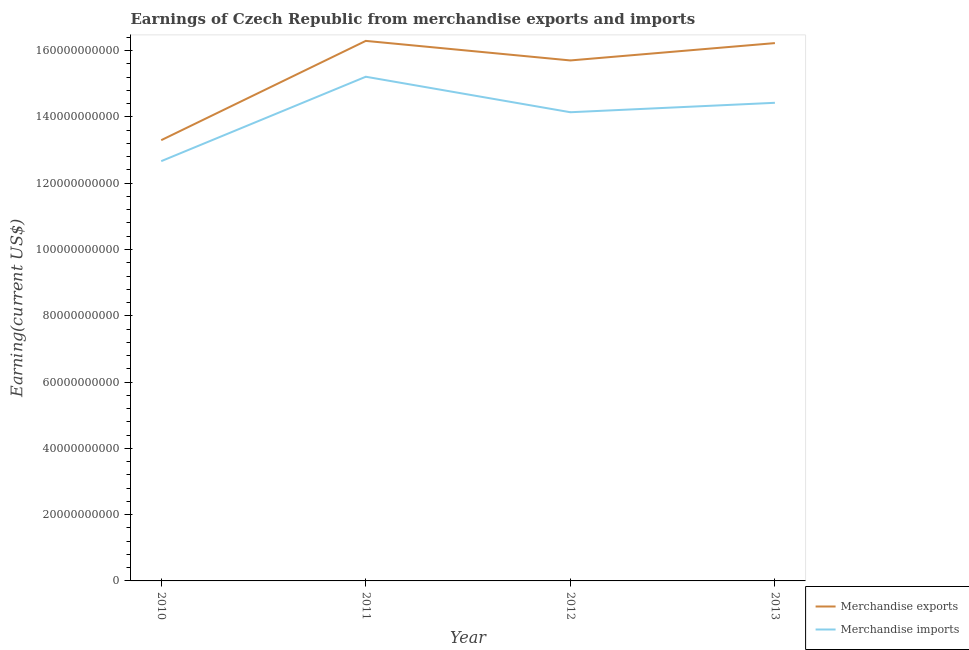Is the number of lines equal to the number of legend labels?
Offer a terse response. Yes. What is the earnings from merchandise imports in 2012?
Offer a terse response. 1.41e+11. Across all years, what is the maximum earnings from merchandise imports?
Provide a short and direct response. 1.52e+11. Across all years, what is the minimum earnings from merchandise exports?
Your answer should be very brief. 1.33e+11. In which year was the earnings from merchandise exports maximum?
Give a very brief answer. 2011. In which year was the earnings from merchandise exports minimum?
Ensure brevity in your answer.  2010. What is the total earnings from merchandise imports in the graph?
Offer a terse response. 5.64e+11. What is the difference between the earnings from merchandise exports in 2011 and that in 2013?
Offer a very short reply. 6.65e+08. What is the difference between the earnings from merchandise imports in 2012 and the earnings from merchandise exports in 2011?
Make the answer very short. -2.15e+1. What is the average earnings from merchandise imports per year?
Your answer should be compact. 1.41e+11. In the year 2012, what is the difference between the earnings from merchandise exports and earnings from merchandise imports?
Provide a succinct answer. 1.56e+1. What is the ratio of the earnings from merchandise exports in 2010 to that in 2012?
Your answer should be very brief. 0.85. Is the earnings from merchandise imports in 2012 less than that in 2013?
Your answer should be compact. Yes. What is the difference between the highest and the second highest earnings from merchandise exports?
Provide a short and direct response. 6.65e+08. What is the difference between the highest and the lowest earnings from merchandise imports?
Offer a very short reply. 2.55e+1. Is the sum of the earnings from merchandise imports in 2010 and 2013 greater than the maximum earnings from merchandise exports across all years?
Provide a short and direct response. Yes. Is the earnings from merchandise imports strictly greater than the earnings from merchandise exports over the years?
Keep it short and to the point. No. How many lines are there?
Give a very brief answer. 2. How many years are there in the graph?
Your response must be concise. 4. Does the graph contain any zero values?
Your answer should be very brief. No. How many legend labels are there?
Provide a succinct answer. 2. What is the title of the graph?
Provide a succinct answer. Earnings of Czech Republic from merchandise exports and imports. Does "Private creditors" appear as one of the legend labels in the graph?
Keep it short and to the point. No. What is the label or title of the Y-axis?
Offer a terse response. Earning(current US$). What is the Earning(current US$) of Merchandise exports in 2010?
Your answer should be compact. 1.33e+11. What is the Earning(current US$) of Merchandise imports in 2010?
Offer a terse response. 1.27e+11. What is the Earning(current US$) of Merchandise exports in 2011?
Give a very brief answer. 1.63e+11. What is the Earning(current US$) of Merchandise imports in 2011?
Make the answer very short. 1.52e+11. What is the Earning(current US$) in Merchandise exports in 2012?
Provide a succinct answer. 1.57e+11. What is the Earning(current US$) in Merchandise imports in 2012?
Provide a succinct answer. 1.41e+11. What is the Earning(current US$) in Merchandise exports in 2013?
Offer a terse response. 1.62e+11. What is the Earning(current US$) in Merchandise imports in 2013?
Ensure brevity in your answer.  1.44e+11. Across all years, what is the maximum Earning(current US$) in Merchandise exports?
Your answer should be very brief. 1.63e+11. Across all years, what is the maximum Earning(current US$) of Merchandise imports?
Make the answer very short. 1.52e+11. Across all years, what is the minimum Earning(current US$) in Merchandise exports?
Your answer should be very brief. 1.33e+11. Across all years, what is the minimum Earning(current US$) of Merchandise imports?
Your answer should be compact. 1.27e+11. What is the total Earning(current US$) in Merchandise exports in the graph?
Make the answer very short. 6.15e+11. What is the total Earning(current US$) of Merchandise imports in the graph?
Offer a very short reply. 5.64e+11. What is the difference between the Earning(current US$) of Merchandise exports in 2010 and that in 2011?
Offer a terse response. -3.00e+1. What is the difference between the Earning(current US$) of Merchandise imports in 2010 and that in 2011?
Ensure brevity in your answer.  -2.55e+1. What is the difference between the Earning(current US$) of Merchandise exports in 2010 and that in 2012?
Offer a very short reply. -2.41e+1. What is the difference between the Earning(current US$) of Merchandise imports in 2010 and that in 2012?
Provide a short and direct response. -1.48e+1. What is the difference between the Earning(current US$) of Merchandise exports in 2010 and that in 2013?
Give a very brief answer. -2.93e+1. What is the difference between the Earning(current US$) in Merchandise imports in 2010 and that in 2013?
Keep it short and to the point. -1.76e+1. What is the difference between the Earning(current US$) in Merchandise exports in 2011 and that in 2012?
Make the answer very short. 5.90e+09. What is the difference between the Earning(current US$) of Merchandise imports in 2011 and that in 2012?
Your answer should be compact. 1.07e+1. What is the difference between the Earning(current US$) in Merchandise exports in 2011 and that in 2013?
Offer a terse response. 6.65e+08. What is the difference between the Earning(current US$) in Merchandise imports in 2011 and that in 2013?
Offer a terse response. 7.87e+09. What is the difference between the Earning(current US$) of Merchandise exports in 2012 and that in 2013?
Your response must be concise. -5.23e+09. What is the difference between the Earning(current US$) of Merchandise imports in 2012 and that in 2013?
Make the answer very short. -2.85e+09. What is the difference between the Earning(current US$) in Merchandise exports in 2010 and the Earning(current US$) in Merchandise imports in 2011?
Give a very brief answer. -1.91e+1. What is the difference between the Earning(current US$) in Merchandise exports in 2010 and the Earning(current US$) in Merchandise imports in 2012?
Ensure brevity in your answer.  -8.43e+09. What is the difference between the Earning(current US$) of Merchandise exports in 2010 and the Earning(current US$) of Merchandise imports in 2013?
Your answer should be very brief. -1.13e+1. What is the difference between the Earning(current US$) of Merchandise exports in 2011 and the Earning(current US$) of Merchandise imports in 2012?
Offer a terse response. 2.15e+1. What is the difference between the Earning(current US$) of Merchandise exports in 2011 and the Earning(current US$) of Merchandise imports in 2013?
Provide a short and direct response. 1.87e+1. What is the difference between the Earning(current US$) in Merchandise exports in 2012 and the Earning(current US$) in Merchandise imports in 2013?
Your answer should be very brief. 1.28e+1. What is the average Earning(current US$) of Merchandise exports per year?
Your response must be concise. 1.54e+11. What is the average Earning(current US$) in Merchandise imports per year?
Provide a succinct answer. 1.41e+11. In the year 2010, what is the difference between the Earning(current US$) of Merchandise exports and Earning(current US$) of Merchandise imports?
Your answer should be compact. 6.33e+09. In the year 2011, what is the difference between the Earning(current US$) in Merchandise exports and Earning(current US$) in Merchandise imports?
Your response must be concise. 1.08e+1. In the year 2012, what is the difference between the Earning(current US$) of Merchandise exports and Earning(current US$) of Merchandise imports?
Make the answer very short. 1.56e+1. In the year 2013, what is the difference between the Earning(current US$) of Merchandise exports and Earning(current US$) of Merchandise imports?
Ensure brevity in your answer.  1.80e+1. What is the ratio of the Earning(current US$) in Merchandise exports in 2010 to that in 2011?
Provide a succinct answer. 0.82. What is the ratio of the Earning(current US$) in Merchandise imports in 2010 to that in 2011?
Your answer should be compact. 0.83. What is the ratio of the Earning(current US$) in Merchandise exports in 2010 to that in 2012?
Your answer should be very brief. 0.85. What is the ratio of the Earning(current US$) in Merchandise imports in 2010 to that in 2012?
Your response must be concise. 0.9. What is the ratio of the Earning(current US$) of Merchandise exports in 2010 to that in 2013?
Your response must be concise. 0.82. What is the ratio of the Earning(current US$) in Merchandise imports in 2010 to that in 2013?
Your response must be concise. 0.88. What is the ratio of the Earning(current US$) in Merchandise exports in 2011 to that in 2012?
Offer a very short reply. 1.04. What is the ratio of the Earning(current US$) of Merchandise imports in 2011 to that in 2012?
Provide a succinct answer. 1.08. What is the ratio of the Earning(current US$) in Merchandise imports in 2011 to that in 2013?
Make the answer very short. 1.05. What is the ratio of the Earning(current US$) in Merchandise exports in 2012 to that in 2013?
Provide a short and direct response. 0.97. What is the ratio of the Earning(current US$) in Merchandise imports in 2012 to that in 2013?
Offer a very short reply. 0.98. What is the difference between the highest and the second highest Earning(current US$) of Merchandise exports?
Offer a very short reply. 6.65e+08. What is the difference between the highest and the second highest Earning(current US$) in Merchandise imports?
Offer a very short reply. 7.87e+09. What is the difference between the highest and the lowest Earning(current US$) of Merchandise exports?
Keep it short and to the point. 3.00e+1. What is the difference between the highest and the lowest Earning(current US$) in Merchandise imports?
Provide a succinct answer. 2.55e+1. 